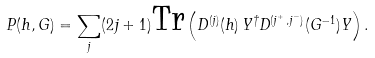<formula> <loc_0><loc_0><loc_500><loc_500>P ( h , G ) = \sum _ { j } ( 2 j + 1 ) \text {Tr} \left ( D ^ { ( j ) } ( h ) \, Y ^ { \dagger } D ^ { ( j ^ { + } \, , j ^ { - } ) } ( G ^ { - 1 } ) Y \right ) .</formula> 